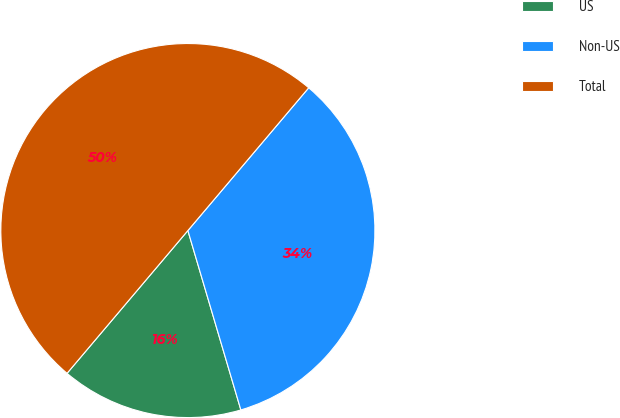Convert chart to OTSL. <chart><loc_0><loc_0><loc_500><loc_500><pie_chart><fcel>US<fcel>Non-US<fcel>Total<nl><fcel>15.75%<fcel>34.25%<fcel>50.0%<nl></chart> 